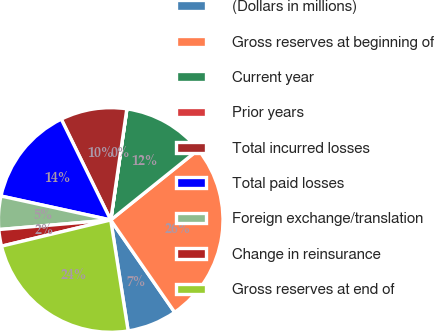Convert chart to OTSL. <chart><loc_0><loc_0><loc_500><loc_500><pie_chart><fcel>(Dollars in millions)<fcel>Gross reserves at beginning of<fcel>Current year<fcel>Prior years<fcel>Total incurred losses<fcel>Total paid losses<fcel>Foreign exchange/translation<fcel>Change in reinsurance<fcel>Gross reserves at end of<nl><fcel>7.16%<fcel>26.12%<fcel>11.93%<fcel>0.01%<fcel>9.55%<fcel>14.32%<fcel>4.78%<fcel>2.39%<fcel>23.73%<nl></chart> 